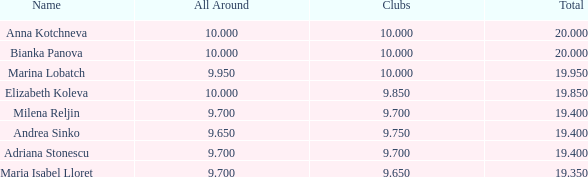What are the lowest clubs that have a place greater than 5, with an all around greater than 9.7? None. 